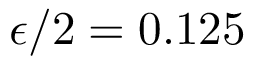Convert formula to latex. <formula><loc_0><loc_0><loc_500><loc_500>\epsilon / 2 = 0 . 1 2 5</formula> 